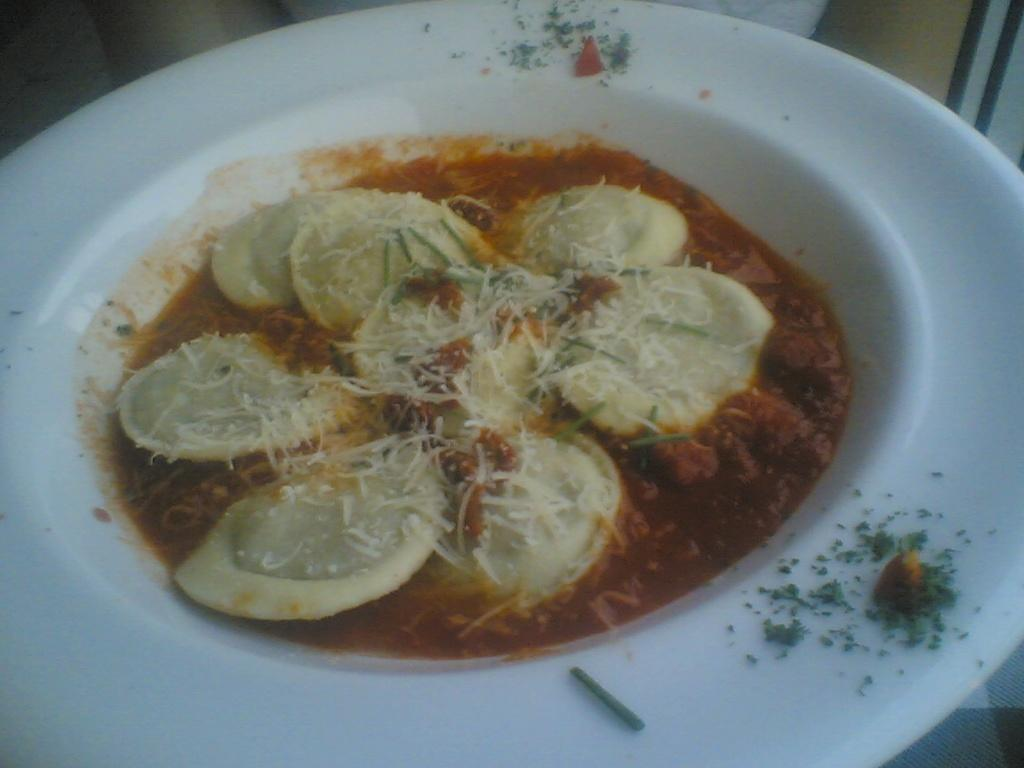What is the main object in the center of the image? There is a white color plate in the center of the image. What is placed on the plate? There is a food item on the plate. What type of nose can be seen on the plate in the image? There is no nose present on the plate in the image. What emotion is the food item expressing in the image? Food items do not express emotions, so this question cannot be answered. 